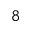Convert formula to latex. <formula><loc_0><loc_0><loc_500><loc_500>^ { 8 }</formula> 